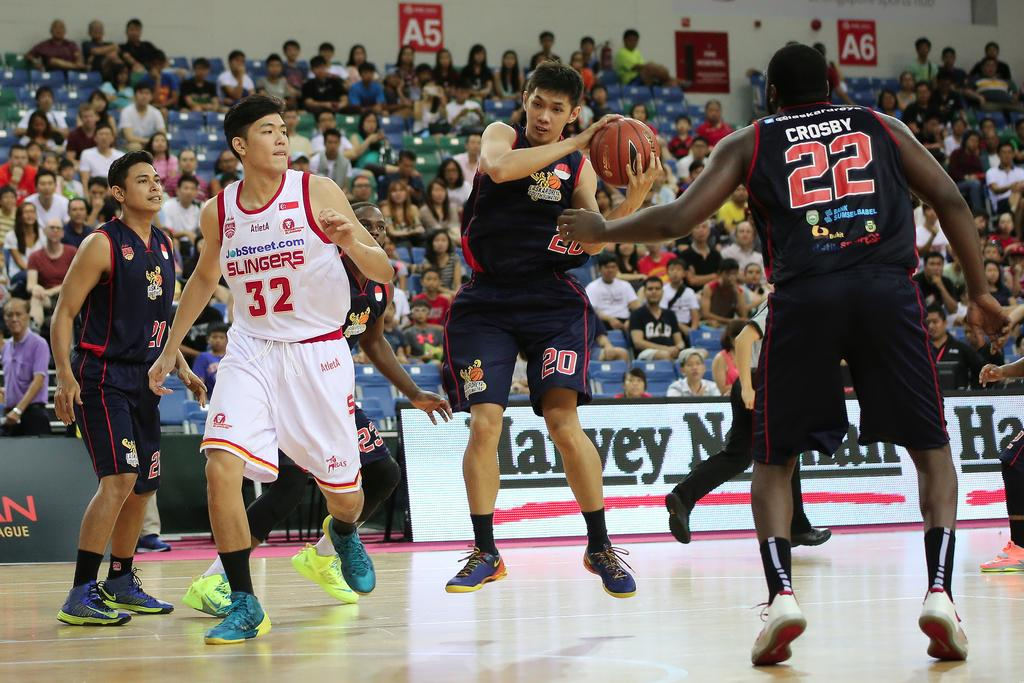<image>
Summarize the visual content of the image. A basketball player named Crosby works to defend his teammate from various opponents. 